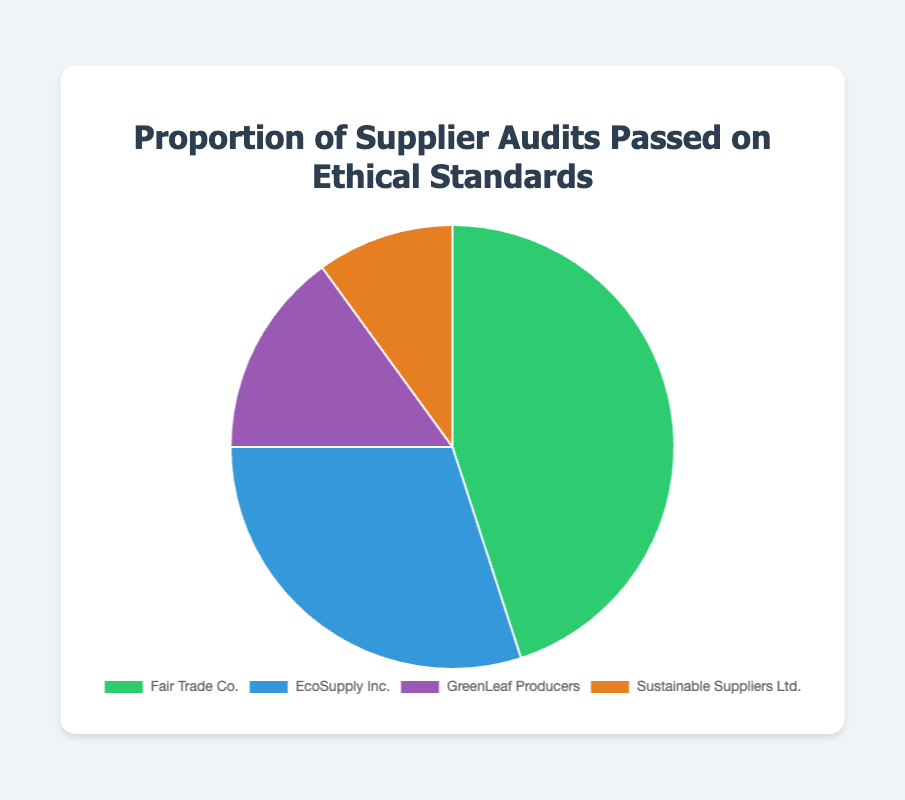What percentage of audits were passed by Fair Trade Co.? Looking at the pie chart, the section for Fair Trade Co. shows 45%.
Answer: 45% Which entity has the lowest proportion of passed audits? By observing the pie chart, Sustainable Suppliers Ltd. has the smallest section, denoting 10%.
Answer: Sustainable Suppliers Ltd How much higher is Fair Trade Co.'s audit pass rate compared to EcoSupply Inc.? Fair Trade Co. has a 45% pass rate, while EcoSupply Inc. has 30%. The difference is 45% - 30% = 15%.
Answer: 15% What is the combined percentage of passed audits for GreenLeaf Producers and Sustainable Suppliers Ltd.? GreenLeaf Producers have 15%, and Sustainable Suppliers Ltd. have 10%. Combined, this is 15% + 10% = 25%.
Answer: 25% Which entity has a 20% higher audit pass rate than the lowest percentage? Sustainable Suppliers Ltd. has the lowest at 10%. Adding 20% leads to 30%, which matches EcoSupply Inc.'s pass rate.
Answer: EcoSupply Inc Is there any entity that has exactly half the audit pass rate of Fair Trade Co.? The audit pass rate of Fair Trade Co. is 45%. Half of 45% is 22.5%. No entity has a 22.5% pass rate, so the answer is no.
Answer: No If we wanted the aggregate percentage of passed audits for the top two entities, what would that percentage be? The top two entities are Fair Trade Co. (45%) and EcoSupply Inc. (30%). Together, they account for 45% + 30% = 75%.
Answer: 75% What color represents GreenLeaf Producers in the pie chart? Observing the pie chart, the section for GreenLeaf Producers is represented by the color purple.
Answer: Purple Which two entities together have an audit pass rate less than that of Fair Trade Co.? GreenLeaf Producers have 15%, and Sustainable Suppliers Ltd. have 10%. Together, they have 15% + 10% = 25%, which is less than Fair Trade Co.'s 45%.
Answer: GreenLeaf Producers & Sustainable Suppliers Ltd Compare the sections for EcoSupply Inc. and GreenLeaf Producers in terms of size. EcoSupply Inc. (30%) has a larger section compared to GreenLeaf Producers (15%) based on their respective pass rates.
Answer: EcoSupply Inc. bigger 